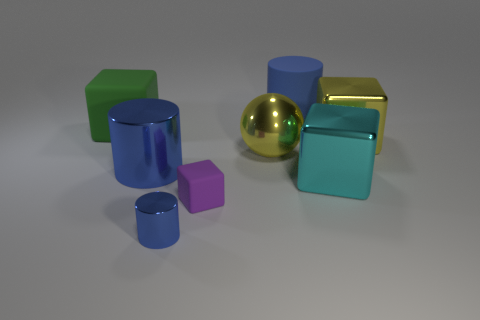Which object appears to be different from the others, and why? The golden sphere stands out among the other objects due to its shape. While the rest of the objects are some form of cuboid or cylinder, it is the only sphere, which makes it unique in this set of shapes. 